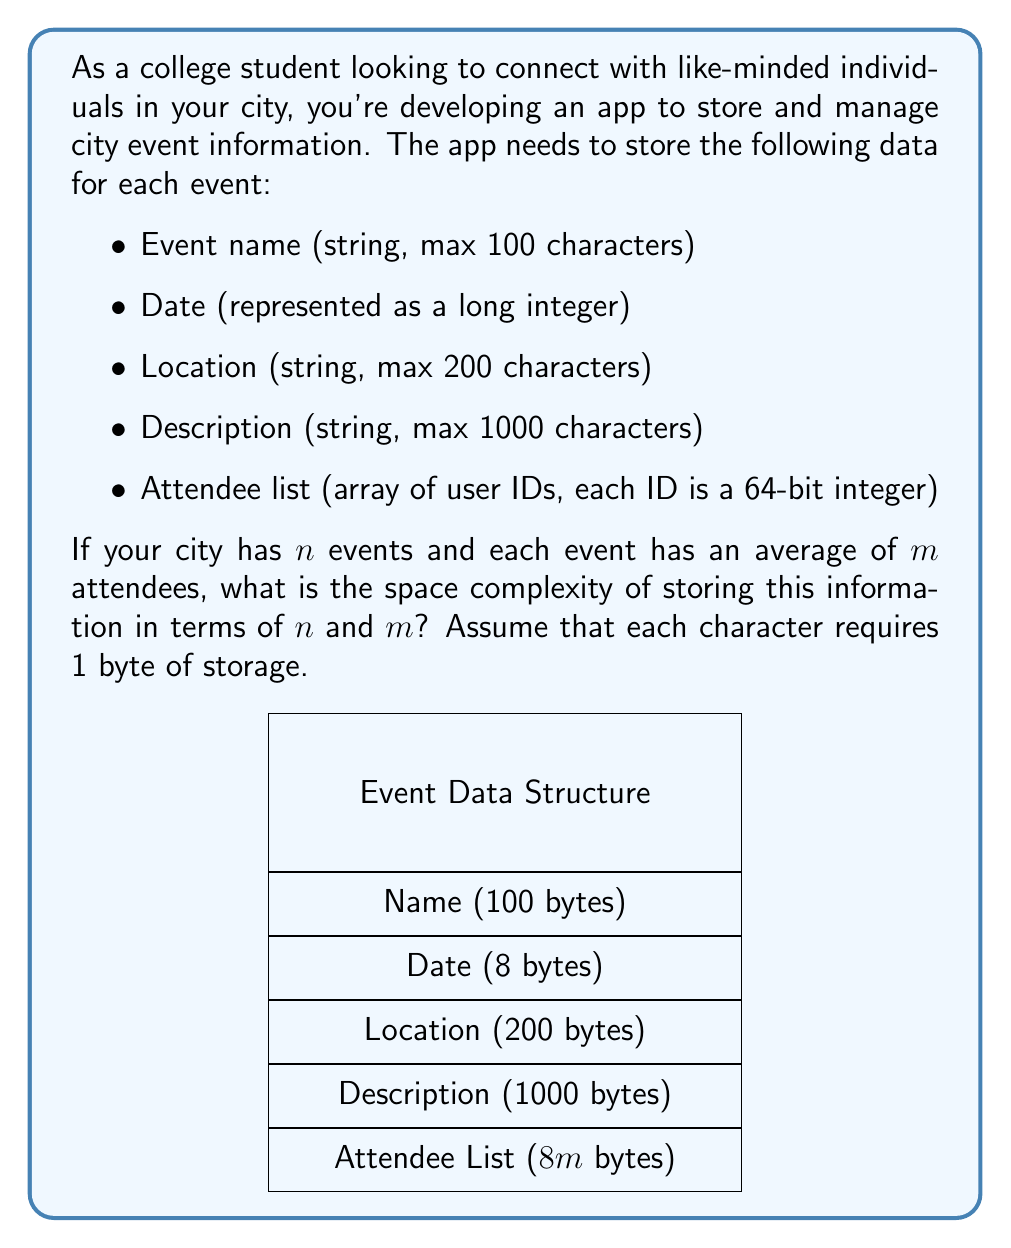Show me your answer to this math problem. Let's break down the space requirements for each component of an event:

1. Event name: 100 characters * 1 byte/character = 100 bytes
2. Date: 1 long integer = 8 bytes
3. Location: 200 characters * 1 byte/character = 200 bytes
4. Description: 1000 characters * 1 byte/character = 1000 bytes
5. Attendee list: $m$ attendees * 64 bits/attendee = $8m$ bytes

Total space for one event:
$$ S_{event} = 100 + 8 + 200 + 1000 + 8m = 1308 + 8m \text{ bytes} $$

For $n$ events, the total space required would be:
$$ S_{total} = n * S_{event} = n * (1308 + 8m) = 1308n + 8mn \text{ bytes} $$

To express this in Big O notation, we can simplify by removing the constant factors:
$$ O(n + mn) $$

Since $m$ can vary independently of $n$, we keep both terms. This can be further simplified to:
$$ O(n(1 + m)) $$

However, in computational complexity theory, we typically express space complexity in terms of bits rather than bytes. Since 1 byte = 8 bits, our final space complexity is:
$$ O(n(1 + m)) \text{ bytes} = O(8n(1 + m)) \text{ bits} = O(n(1 + m)) \text{ bits} $$

The constant factor of 8 is dropped in Big O notation.
Answer: $O(n(1 + m))$ bits 